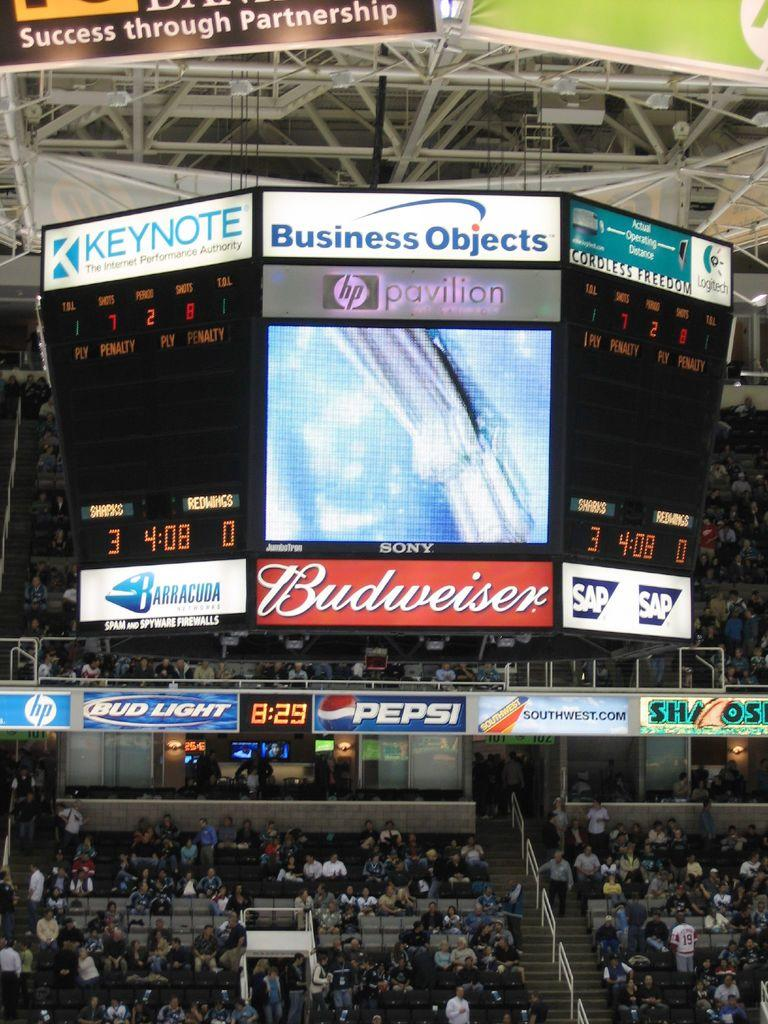Where was the image taken? The image was taken in a stadium. What can be seen in the center of the image? There are screens in the center of the image. What other objects are visible in the image? There are boards visible in the image. What type of seating is present at the bottom of the image? Bleachers are present at the bottom of the image. What is the crowd doing in the image? There is a crowd sitting on the bleachers. What type of tail can be seen on the bushes in the image? There are no bushes present in the image, so there is no tail to observe. 